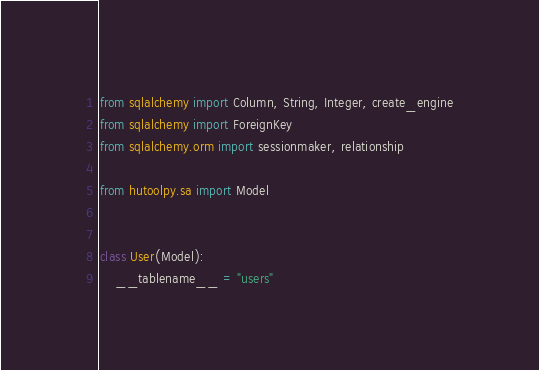<code> <loc_0><loc_0><loc_500><loc_500><_Python_>from sqlalchemy import Column, String, Integer, create_engine
from sqlalchemy import ForeignKey
from sqlalchemy.orm import sessionmaker, relationship

from hutoolpy.sa import Model


class User(Model):
    __tablename__ = "users"
</code> 